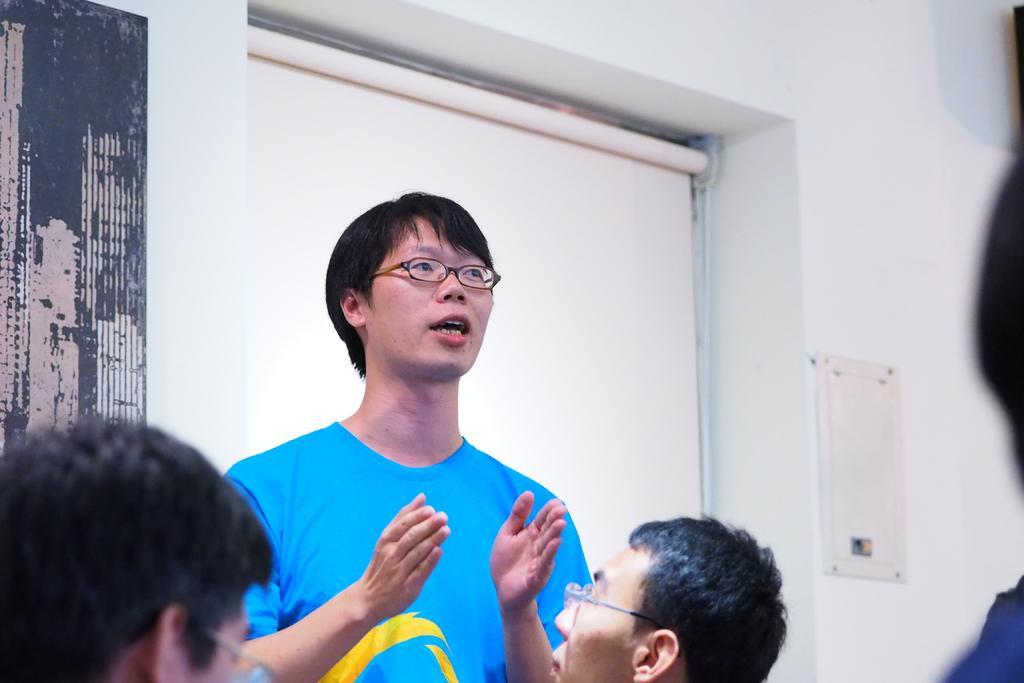In one or two sentences, can you explain what this image depicts? In this picture there is a boy wearing blue color t-shirt and explaining something. In front there are two boy who are standing. In the background we can see white color wall and a curtain blind. 